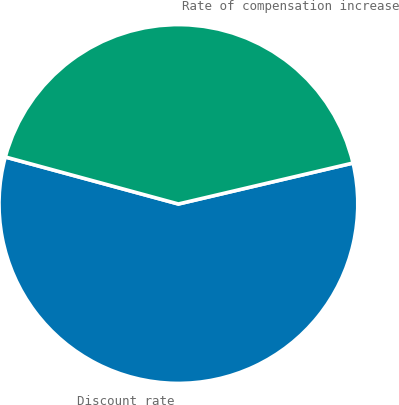Convert chart. <chart><loc_0><loc_0><loc_500><loc_500><pie_chart><fcel>Discount rate<fcel>Rate of compensation increase<nl><fcel>57.89%<fcel>42.11%<nl></chart> 